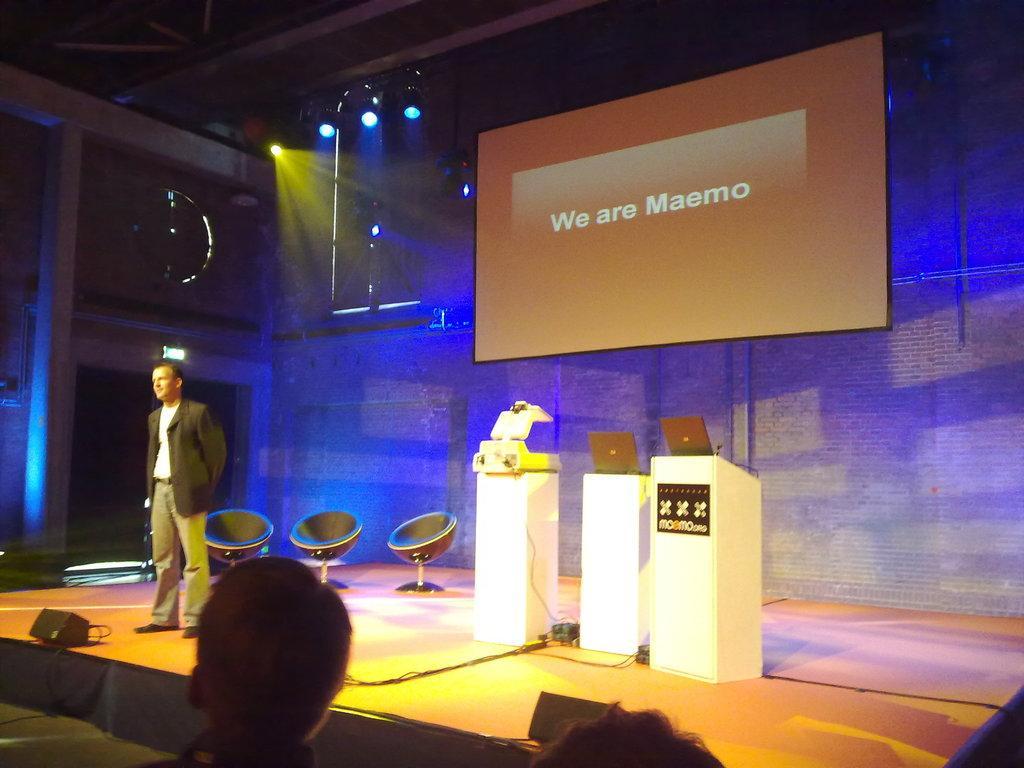Could you give a brief overview of what you see in this image? In this image we can see a person wearing suit standing on stage, there is sound box, there are three chairs, podiums on which there are laptops and in the background of the image there is projector screen, wall and lights, in the foreground of the image we can see heads of some persons. 